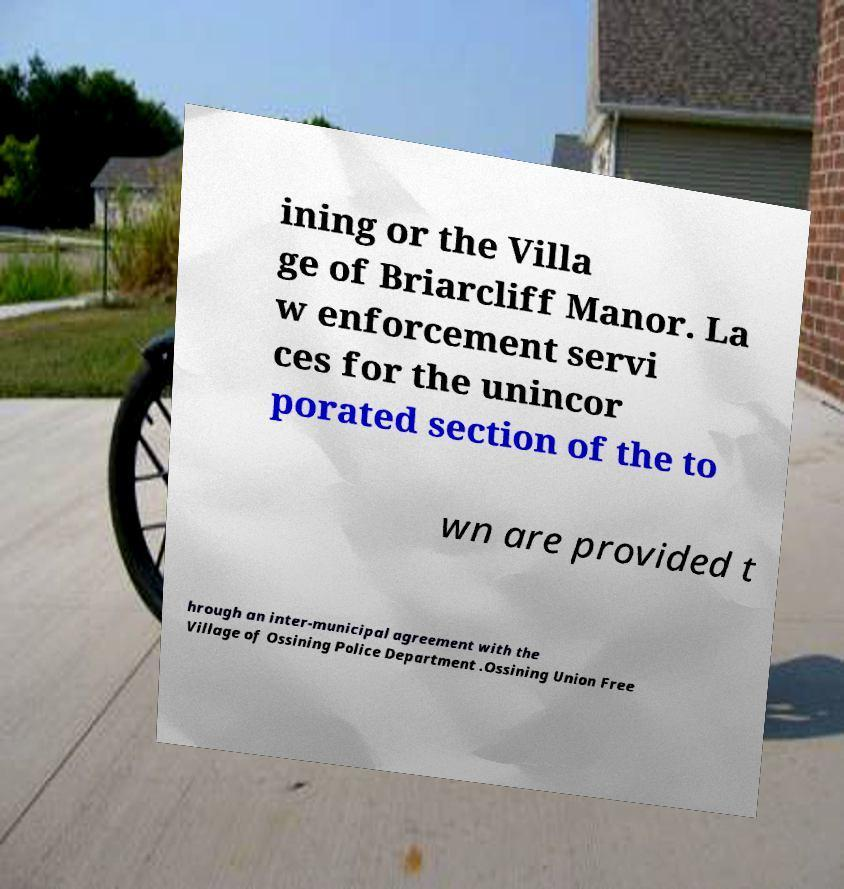Please read and relay the text visible in this image. What does it say? ining or the Villa ge of Briarcliff Manor. La w enforcement servi ces for the unincor porated section of the to wn are provided t hrough an inter-municipal agreement with the Village of Ossining Police Department .Ossining Union Free 